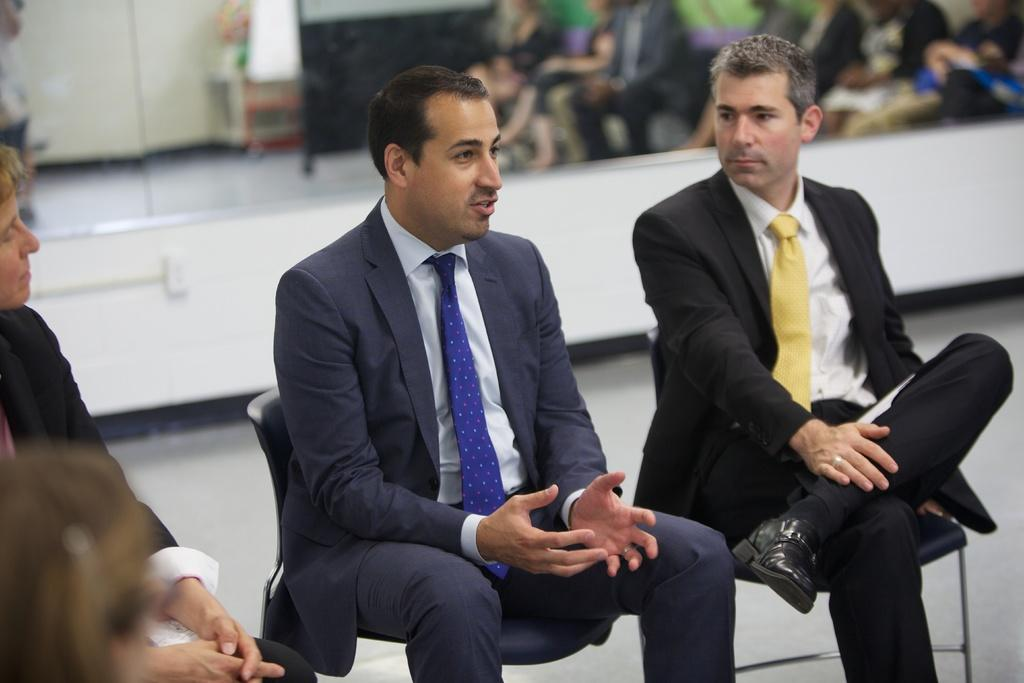What are the persons in the image doing? The persons in the image are sitting on chairs. Where are the chairs located? The chairs are on the floor. What can be seen on the wall in the image? There is a mirror on the wall. What is visible in the mirror? Reflections of persons and objects are visible in the mirror. What color is the bead that is hanging from the eye of the person in the image? There is no bead hanging from the eye of any person in the image. 